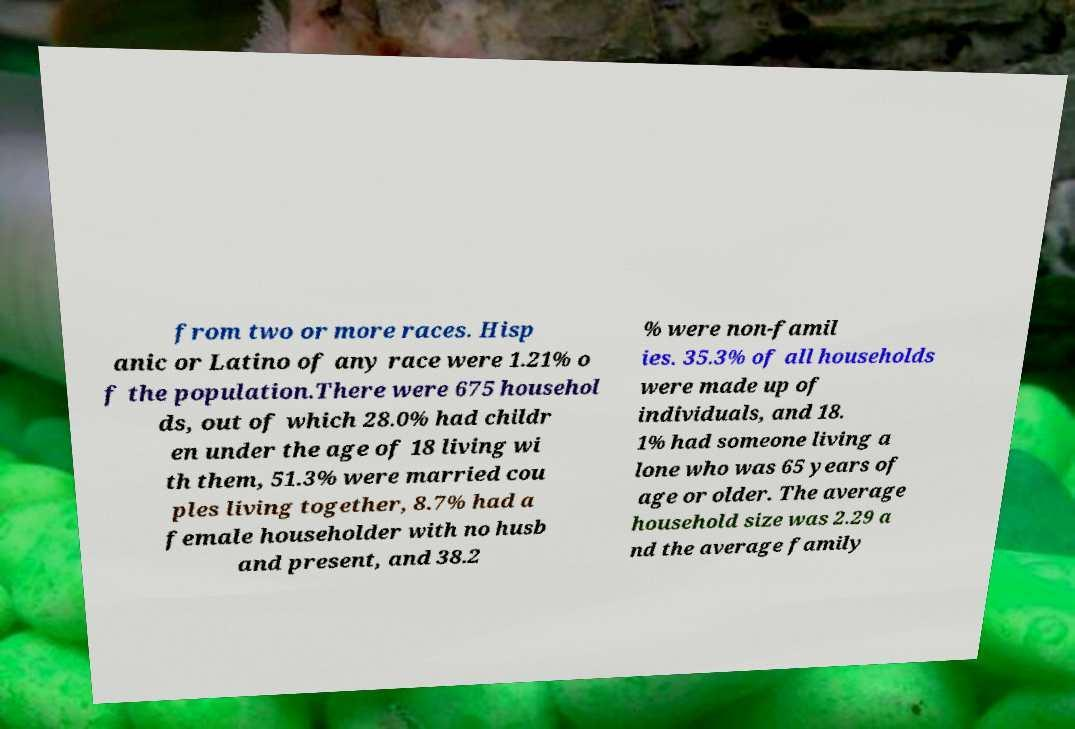Please identify and transcribe the text found in this image. from two or more races. Hisp anic or Latino of any race were 1.21% o f the population.There were 675 househol ds, out of which 28.0% had childr en under the age of 18 living wi th them, 51.3% were married cou ples living together, 8.7% had a female householder with no husb and present, and 38.2 % were non-famil ies. 35.3% of all households were made up of individuals, and 18. 1% had someone living a lone who was 65 years of age or older. The average household size was 2.29 a nd the average family 